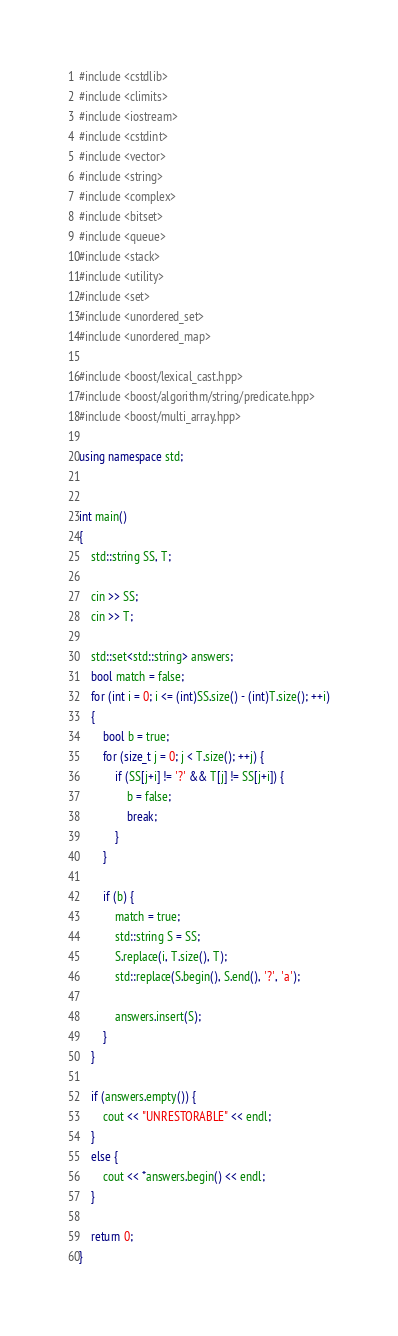Convert code to text. <code><loc_0><loc_0><loc_500><loc_500><_C++_>#include <cstdlib>
#include <climits>
#include <iostream>
#include <cstdint>
#include <vector>
#include <string>
#include <complex>
#include <bitset>
#include <queue>
#include <stack>
#include <utility>
#include <set>
#include <unordered_set>
#include <unordered_map>

#include <boost/lexical_cast.hpp>
#include <boost/algorithm/string/predicate.hpp>
#include <boost/multi_array.hpp>

using namespace std;


int main()
{
    std::string SS, T;

    cin >> SS;
    cin >> T;

    std::set<std::string> answers;
    bool match = false;
    for (int i = 0; i <= (int)SS.size() - (int)T.size(); ++i)
    {
        bool b = true;
        for (size_t j = 0; j < T.size(); ++j) {
            if (SS[j+i] != '?' && T[j] != SS[j+i]) {
                b = false;
                break;
            }
        }

        if (b) {
            match = true;
            std::string S = SS;
            S.replace(i, T.size(), T);
            std::replace(S.begin(), S.end(), '?', 'a');

            answers.insert(S);
        }
    }

    if (answers.empty()) {
        cout << "UNRESTORABLE" << endl;
    }
    else {
        cout << *answers.begin() << endl;
    }

    return 0;
}
</code> 